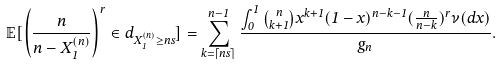Convert formula to latex. <formula><loc_0><loc_0><loc_500><loc_500>\mathbb { E } [ \left ( \frac { n } { n - X _ { 1 } ^ { ( n ) } } \right ) ^ { r } \in d _ { X _ { 1 } ^ { ( n ) } \geq n s } ] = \sum _ { k = \lceil n s \rceil } ^ { n - 1 } \frac { \int _ { 0 } ^ { 1 } { n \choose k + 1 } x ^ { k + 1 } ( 1 - x ) ^ { n - k - 1 } ( \frac { n } { n - k } ) ^ { r } \nu ( d x ) } { g _ { n } } .</formula> 